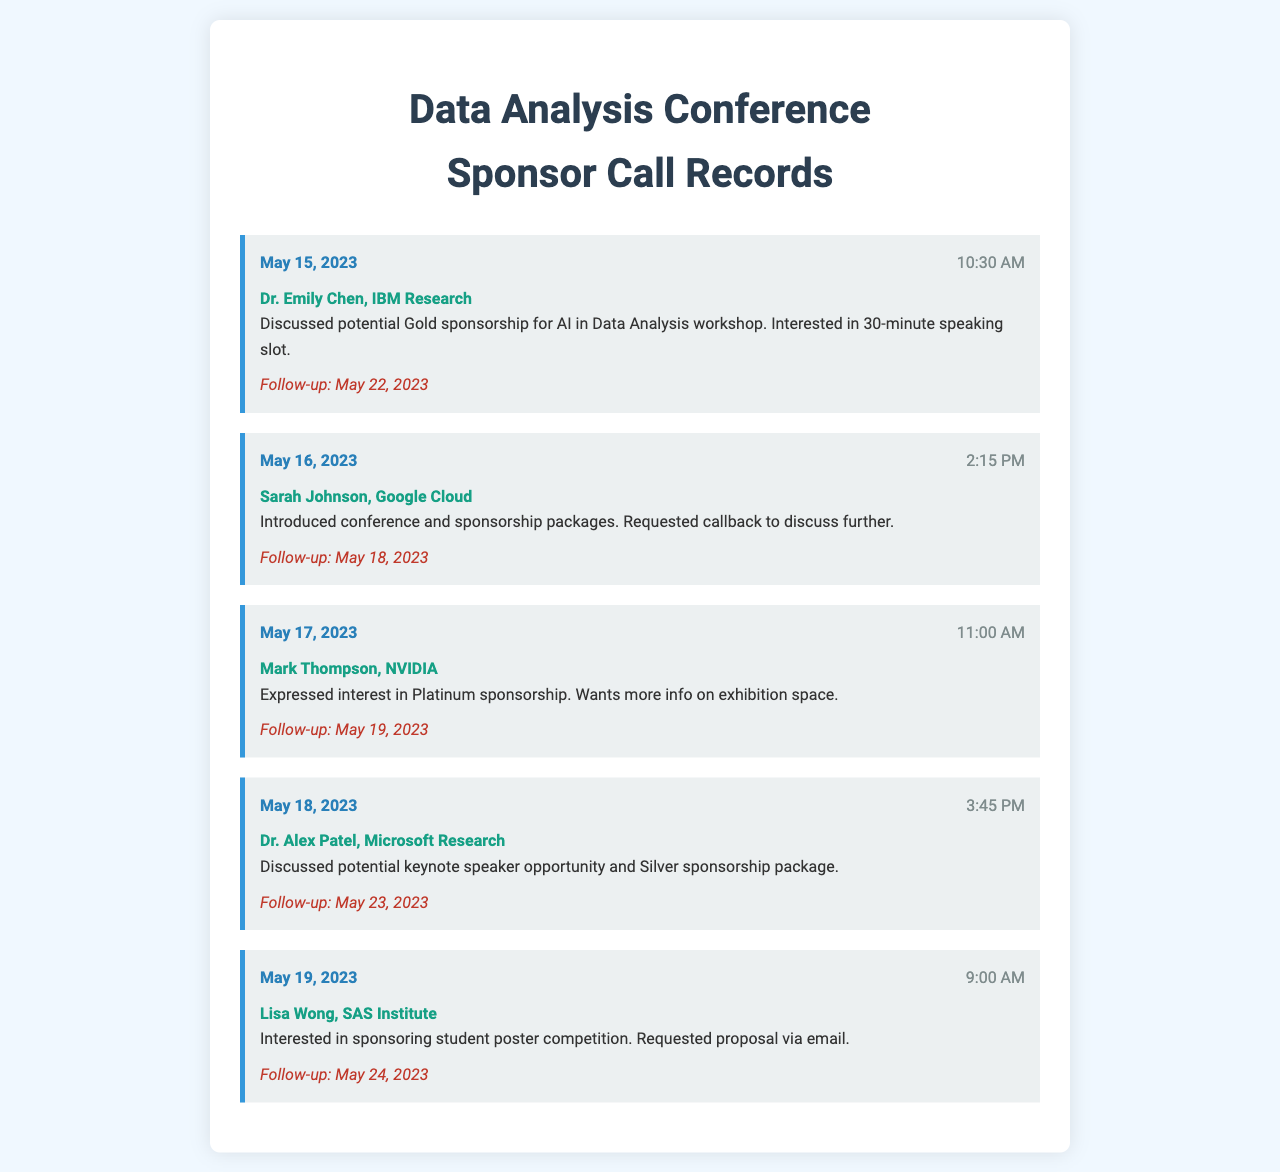What is the date of the call with Dr. Emily Chen? The date of the call with Dr. Emily Chen is mentioned in the call record under her details.
Answer: May 15, 2023 Who did Sarah Johnson represent? Sarah Johnson's affiliation is specified in the call record where her name is mentioned.
Answer: Google Cloud What time was the call with Mark Thompson? The time of the call with Mark Thompson is provided in the call record for that entry.
Answer: 11:00 AM What was discussed during the call with Dr. Alex Patel? The notes for the call with Dr. Alex Patel outline the topics covered in that discussion.
Answer: Keynote speaker opportunity and Silver sponsorship package What follow-up date is scheduled after the call with Lisa Wong? The follow-up date for the call with Lisa Wong is noted in her respective call record.
Answer: May 24, 2023 Which sponsor expressed interest in Platinum sponsorship? The call records indicate the interested sponsors, and Mark Thompson is specifically noted for Platinum sponsorship.
Answer: Mark Thompson How many calls were made on May 19, 2023? The call records need to be checked to count how many are listed for that specific date.
Answer: One What kind of sponsorship was Dr. Emily Chen interested in? The type of sponsorship discussed in the call with Dr. Emily Chen is included in the meeting notes.
Answer: Gold sponsorship What is the request made by Sarah Johnson? The specific request made by Sarah Johnson is specified in the notes for her call.
Answer: Callback to discuss further 